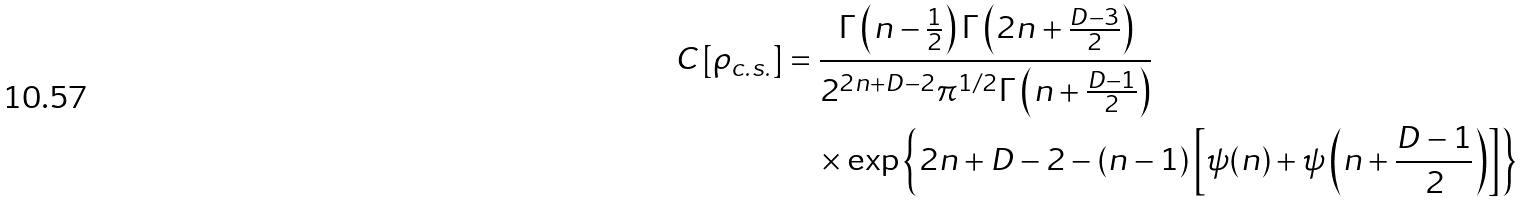Convert formula to latex. <formula><loc_0><loc_0><loc_500><loc_500>C \left [ \rho _ { c . s . } \right ] & = \frac { \Gamma \left ( n - \frac { 1 } { 2 } \right ) \Gamma \left ( 2 n + \frac { D - 3 } { 2 } \right ) } { 2 ^ { 2 n + D - 2 } \pi ^ { 1 / 2 } \Gamma \left ( n + \frac { D - 1 } { 2 } \right ) } \\ & \quad \times \exp \left \{ 2 n + D - 2 - ( n - 1 ) \left [ \psi ( n ) + \psi \left ( n + \frac { D - 1 } { 2 } \right ) \right ] \right \}</formula> 